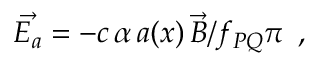Convert formula to latex. <formula><loc_0><loc_0><loc_500><loc_500>\vec { E _ { a } } = - c \, \alpha \, a ( x ) \, \vec { B } / f _ { P Q } \pi \, ,</formula> 